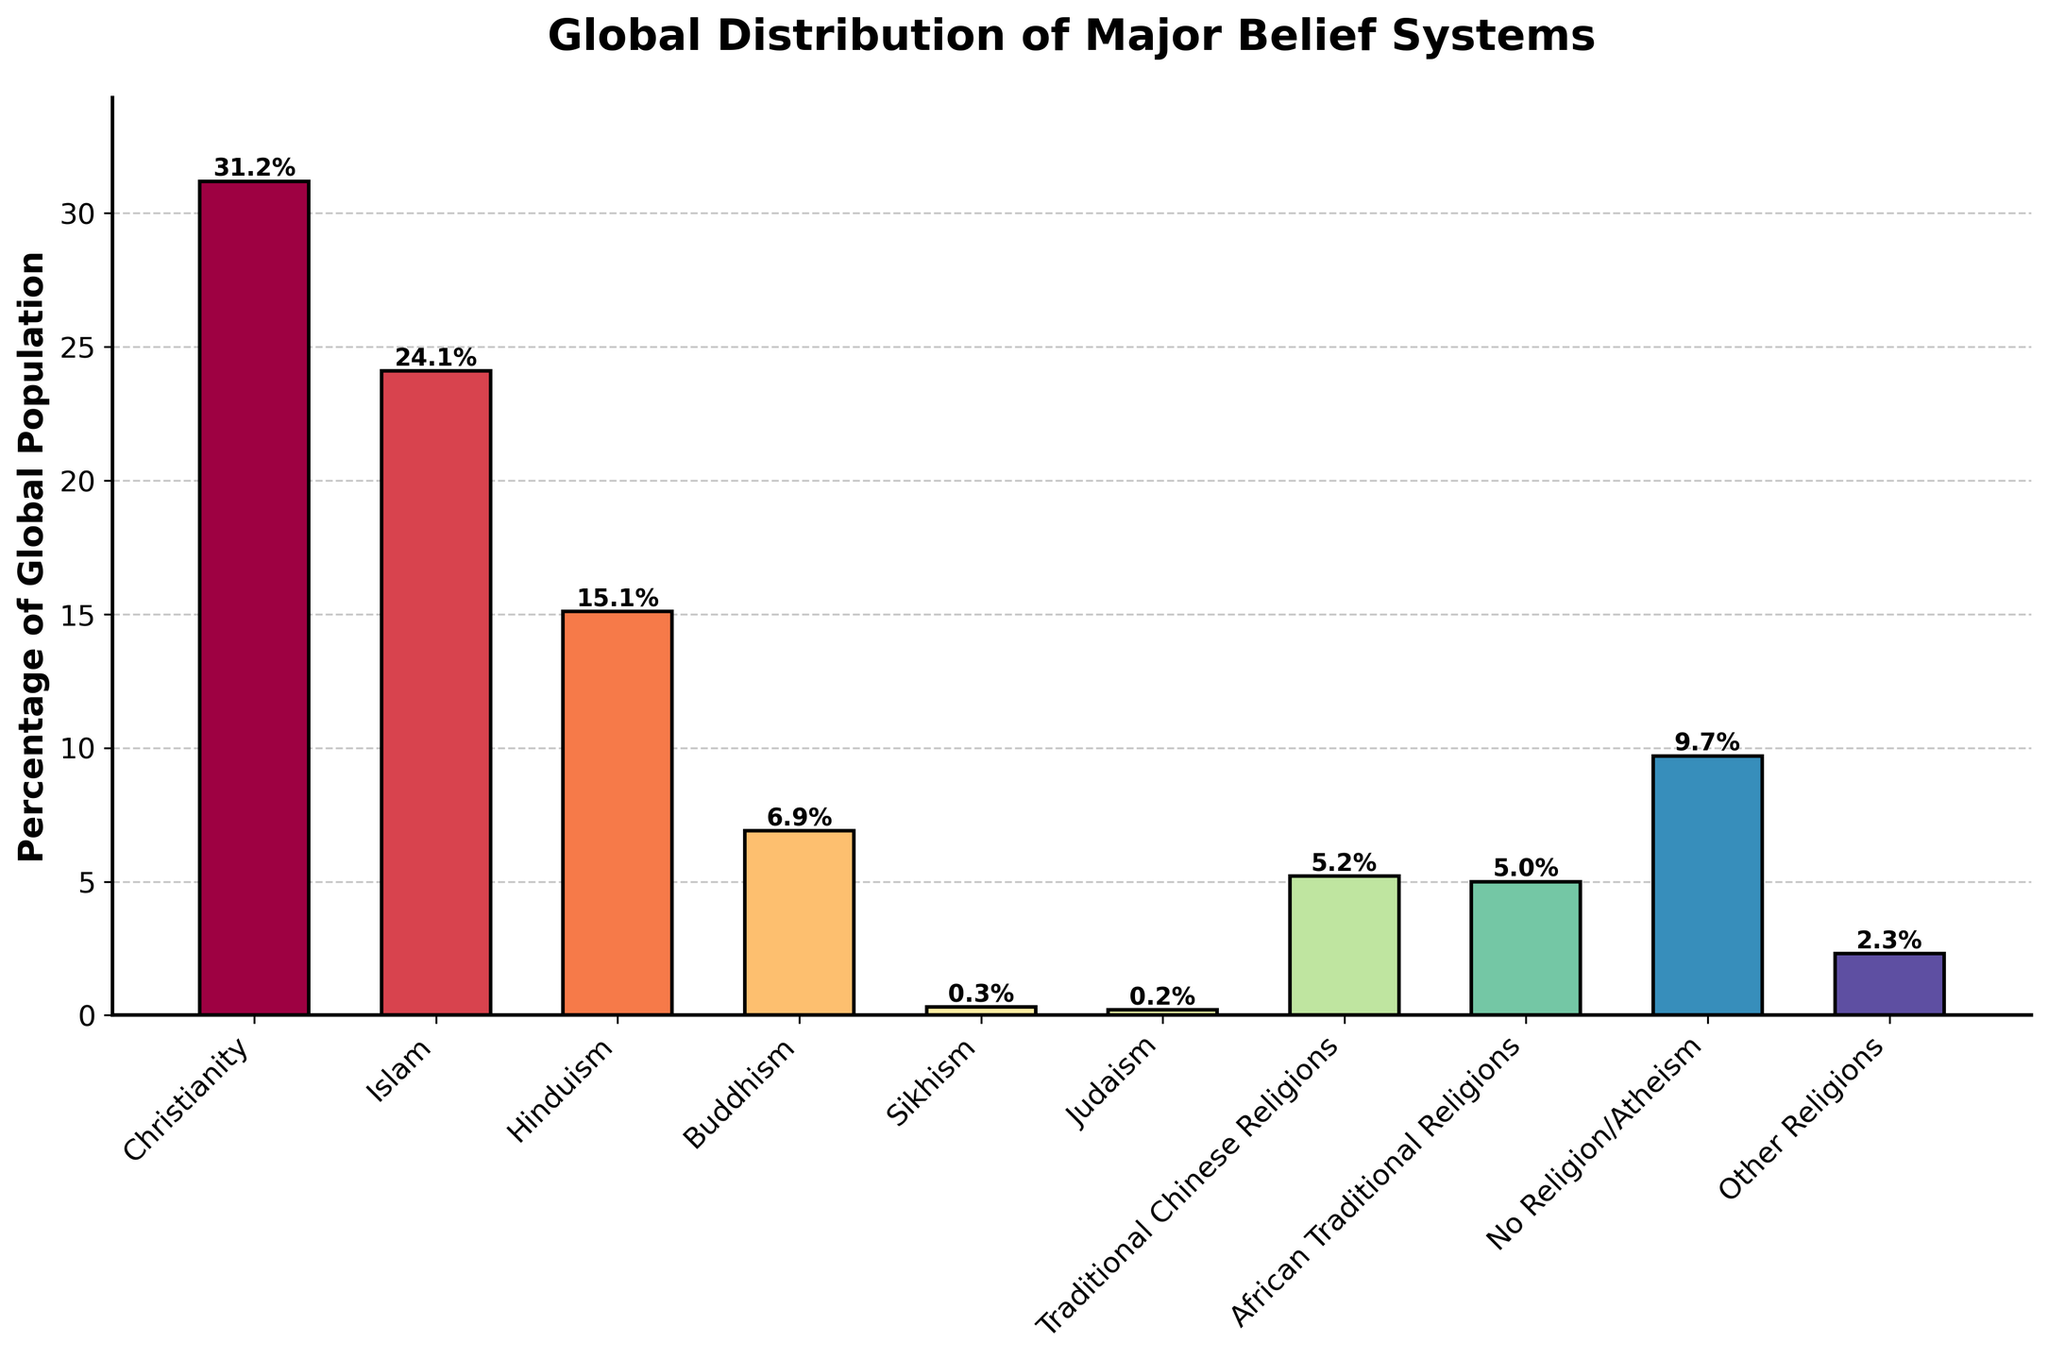What is the percentage of the global population adhering to Christianity? The height of the bar labeled "Christianity" represents the percentage. This height corresponds to a value of 31.2%.
Answer: 31.2% Which belief system has the second largest global population percentage? By comparing the heights of the bars, the tallest bar is "Christianity," and the next tallest bar is "Islam," which corresponds to 24.1%.
Answer: Islam Is the global population percentage of Hinduism greater than Buddhism? The height of the bar for "Hinduism" is 15.1%, and for "Buddhism," it is 6.9%. Comparing these values, 15.1% is greater than 6.9%.
Answer: Yes What is the combined percentage for Traditional Chinese Religions and African Traditional Religions? The height of the bar for Traditional Chinese Religions is 5.2%, and for African Traditional Religions, it is 5.0%. Adding these values: 5.2% + 5.0% = 10.2%.
Answer: 10.2% Which belief system has the smallest global population percentage, and what is that percentage? By comparing all the bars, the shortest bar corresponds to "Judaism," with a height of 0.2%.
Answer: Judaism, 0.2% How many belief systems have more than 20% of the global population adhering to them? Among all the bars, only "Christianity" (31.2%) and "Islam" (24.1%) exceed 20%. Therefore, there are two such belief systems.
Answer: 2 Is the sum of the percentages of Sikhism, Judaism, and Other Religions greater than the percentage of No Religion/Atheism? The heights are Sikhism: 0.3%, Judaism: 0.2%, and Other Religions: 2.3%. Their sum is 0.3% + 0.2% + 2.3% = 2.8%. The height for No Religion/Atheism is 9.7%. Comparing, 2.8% is not greater than 9.7%.
Answer: No Which belief system has a height closest to the average percentage of the belief systems shown? Calculate the average by summing all percentages and dividing by the number of belief systems: (31.2 + 24.1 + 15.1 + 6.9 + 0.3 + 0.2 + 5.2 + 5.0 + 9.7 + 2.3)/10 = 100/10 = 10%. The bar closest to this average is "No Religion/Atheism" at 9.7%.
Answer: No Religion/Atheism In terms of visual representation, which bars have colors closer to the red spectrum? Colors closer to the red spectrum are typically found at the beginning of the colormap used for the bars. Based on the bar heights and the colormap's gradient from red to blue, the bars for "Christianity," "Islam," and possibly "Hinduism" should have colors closer to red.
Answer: Christianity, Islam, Hinduism If you were to group all belief systems with less than 5% of the global population together, what would be their combined percentage? Find all belief systems with less than 5%: Sikhism (0.3%), Judaism (0.2%), Other Religions (2.3%), Traditional Chinese Religions (5.2%) - not included. Adding: 0.3% + 0.2% + 2.3% = 2.8%. Then include African Traditional Religions (5.0%): 2.8% + 5.0% = 7.8%.
Answer: 7.8% 